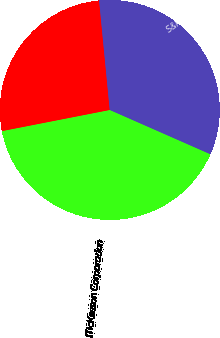<chart> <loc_0><loc_0><loc_500><loc_500><pie_chart><fcel>McKesson Corporation<fcel>S&P 500 Index<fcel>S&P 500 Health Care Index<nl><fcel>40.32%<fcel>26.54%<fcel>33.14%<nl></chart> 